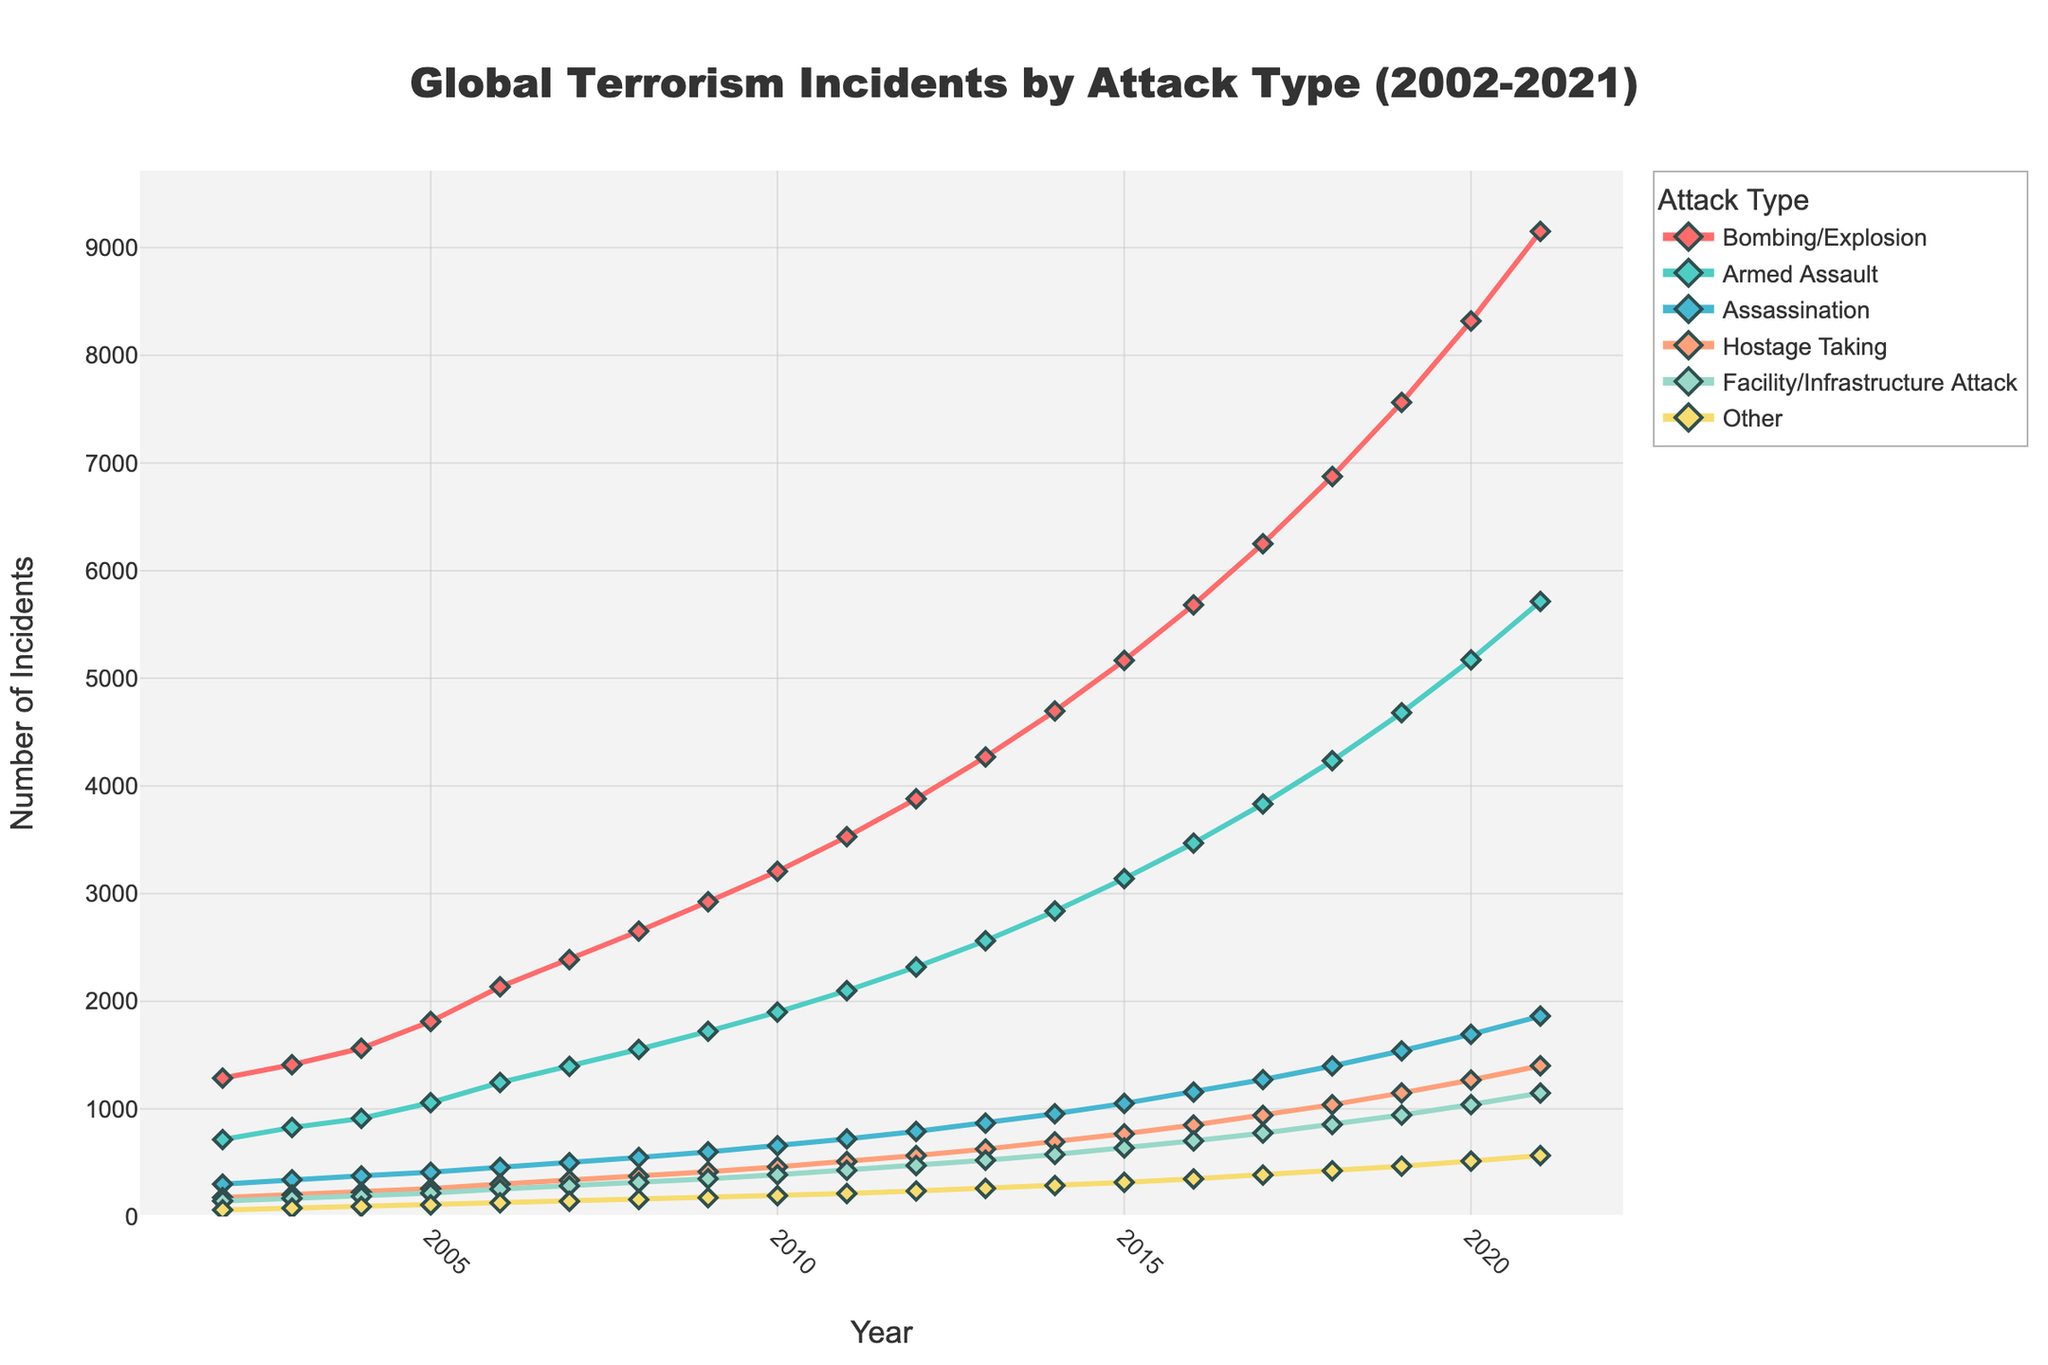What is the total number of bombing/explosion incidents recorded between 2002 and 2021? To find the total number of bombing/explosion incidents over the 20-year period, sum the values in the "Bombing/Explosion" column: 1286 + 1411 + 1563 + 1812 + 2134 + 2387 + 2651 + 2924 + 3207 + 3528 + 3881 + 4269 + 4696 + 5166 + 5682 + 6250 + 6875 + 7563 + 8319 + 9151 = 90565
Answer: 90565 Which attack type shows the steepest increase in the number of incidents over the 20-year period? To determine the steepest increase, subtract the number of incidents in 2002 from those in 2021 for each attack type and compare the differences:
- Bombing/Explosion: 9151 - 1286 = 7865
- Armed Assault: 5714 - 715 = 4999
- Assassination: 1862 - 301 = 1561
- Hostage Taking: 1401 - 176 = 1225
- Facility/Infrastructure Attack: 1147 - 145 = 1002
- Other: 567 - 62 = 505
The Bombing/Explosion type shows the steepest increase.
Answer: Bombing/Explosion In which year did the number of armed assault incidents first exceed 2000? Look at the Armed Assault line and locate the year when the incidents crossed the 2000 mark. This happens in 2011 where the incidents recorded were 2098.
Answer: 2011 How does the count of facility/infrastructure attack incidents in 2016 compare to that of 2012? Extract the counts for the facility/infrastructure attack incidents in 2016 and 2012, then compare them:
- 2016: 703
- 2012: 474
703 is greater than 474.
Answer: Greater What is the average annual number of assassination incidents for the years 2010 to 2015 inclusive? Sum the number of assassination incidents from 2010 to 2015 and divide by the number of years (6): (658 + 721 + 791 + 868 + 955 + 1051) / 6 = 5044 / 6 = 840.67
Answer: 840.67 Identify the attack type with the least variability in number of incidents over the 20-year period. To determine the least variability, observe the range of values for each attack type. The range is highest value minus lowest value:
- Bombing/Explosion: 9151 - 1286 = 7865
- Armed Assault: 5714 - 715 = 4999
- Assassination: 1862 - 301 = 1561
- Hostage Taking: 1401 - 176 = 1225
- Facility/Infrastructure Attack: 1147 - 145 = 1002
- Other: 567 - 62 = 505
The "Other" category shows the least variability with a range of 505.
Answer: Other What is the trend in hostage taking incidents from 2002 to 2021? Examine the line corresponding to hostage-taking incidents on the graph. The incidents increase steadily over the years, moving from 176 in 2002 to 1401 in 2021.
Answer: Increasing By how much did the number of armed assaults change from 2017 to 2020? Subtract the number of armed assault incidents in 2017 from those in 2020: 5171 - 3833 = 1338
Answer: 1338 Which year saw the highest total number of incidents of all attack types combined? Sum the number of incidents for all attack types for each year and identify the year with the highest total.
For 2021: 9151 + 5714 + 1862 + 1401 + 1147 + 567 = 19842
Similarly, calculate for other years to find 2021 has the highest total.
Answer: 2021 What is the combined number of assassination and bombing/explosion incidents in 2015? Add the assassination and bombing/explosion incidents for the year 2015: 1051 (assassination) + 5166 (bombing/explosion) = 6217
Answer: 6217 